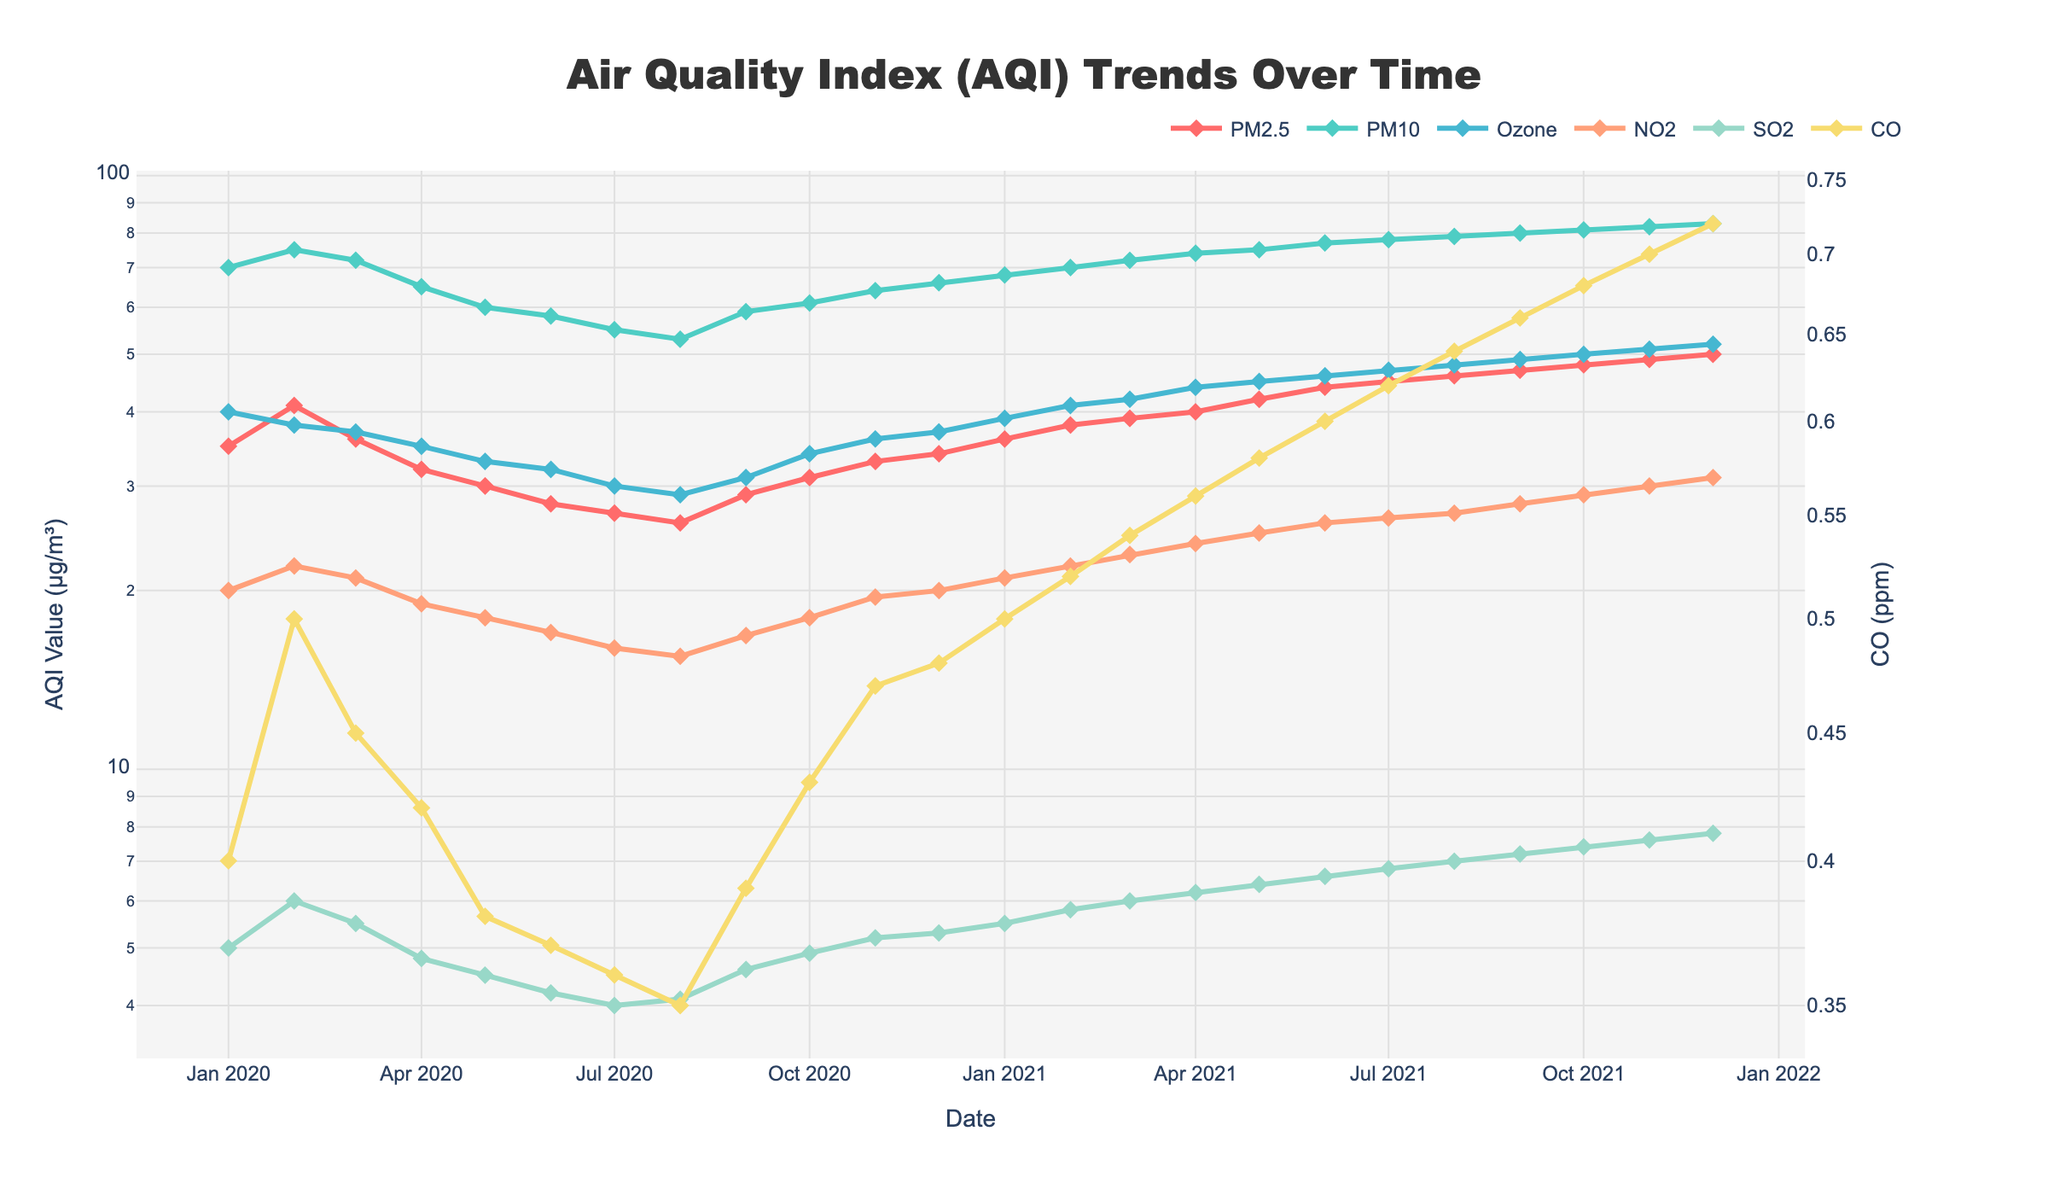What is the title of the plot? The title of the plot is shown at the top of the figure, formatted in a large, bold font. It reads "Air Quality Index (AQI) Trends Over Time".
Answer: Air Quality Index (AQI) Trends Over Time Which pollutant shows the highest AQI value in December 2020? To answer this, look at the data points for December 2020 across all pollutant lines and identify the highest value. PM10 has the highest AQI value of 66 in December 2020.
Answer: PM10 What is the range of AQI values for PM2.5 over the plotted period? To find the range, identify the minimum and maximum AQI values for PM2.5 over the entire period. The minimum value of PM2.5 is 26 (August 2020) and the maximum value is 50 (December 2021). The range is thus 50 - 26 = 24.
Answer: 24 How does the AQI value of NO2 differ from January 2020 to January 2021? Find the AQI values of NO2 for January 2020 and January 2021. NO2 value was 20 in January 2020 and 21 in January 2021. The difference is 21 - 20 = 1.
Answer: 1 Which pollutants showed an increasing trend in AQI values from January 2020 to December 2021? Examine the AQI lines for each pollutant from January 2020 to December 2021 to determine if they demonstrate an increasing trend. All pollutants, including PM2.5, PM10, Ozone, NO2, SO2, and CO, show an increasing trend during this period.
Answer: PM2.5, PM10, Ozone, NO2, SO2, CO Between which months in 2021 did PM2.5 show the largest increase? Look at the AQI values of PM2.5 for each consecutive month in 2021 and find the pair of months with the largest increase. The largest increase is from May 2021 (42) to June 2021 (44), which is an increase of 2.
Answer: May to June Which pollutant had a decreasing AQI trend from January 2020 to August 2020? Observe the AQI lines from January 2020 to August 2020 to find any pollutant that shows a decreasing trend. PM2.5, PM10, Ozone, NO2, SO2, and CO all show a decreasing trend during this period.
Answer: PM2.5, PM10, Ozone, NO2, SO2, CO How do the trends of PM2.5 and PM10 compare from January 2020 to December 2021? Analyze the lines for PM2.5 and PM10 from January 2020 to December 2021 to see how their trends compare. Both PM2.5 and PM10 exhibit an increasing trend, with PM2.5 starting lower and having smaller increments compared to PM10.
Answer: Both increasing What is the average AQI value of SO2 for the year 2021? Identify the AQI values of SO2 for each month in 2021 and calculate the average. The values are 5.5, 5.8, 6.0, 6.2, 6.4, 6.6, 6.8, 7.0, 7.2, 7.4, 7.6, 7.8. Adding these gives 80.3, and the average is 80.3 / 12 ≈ 6.7.
Answer: 6.7 Over what period does CO show a log-scaled range of approximately two orders of magnitude? Considering the log scale, find the maximum and minimum values of CO. The maximum is 0.72 (December 2021), and the minimum is 0.35 (August 2020). The range is less than one order of magnitude.
Answer: Less than one order of magnitude 